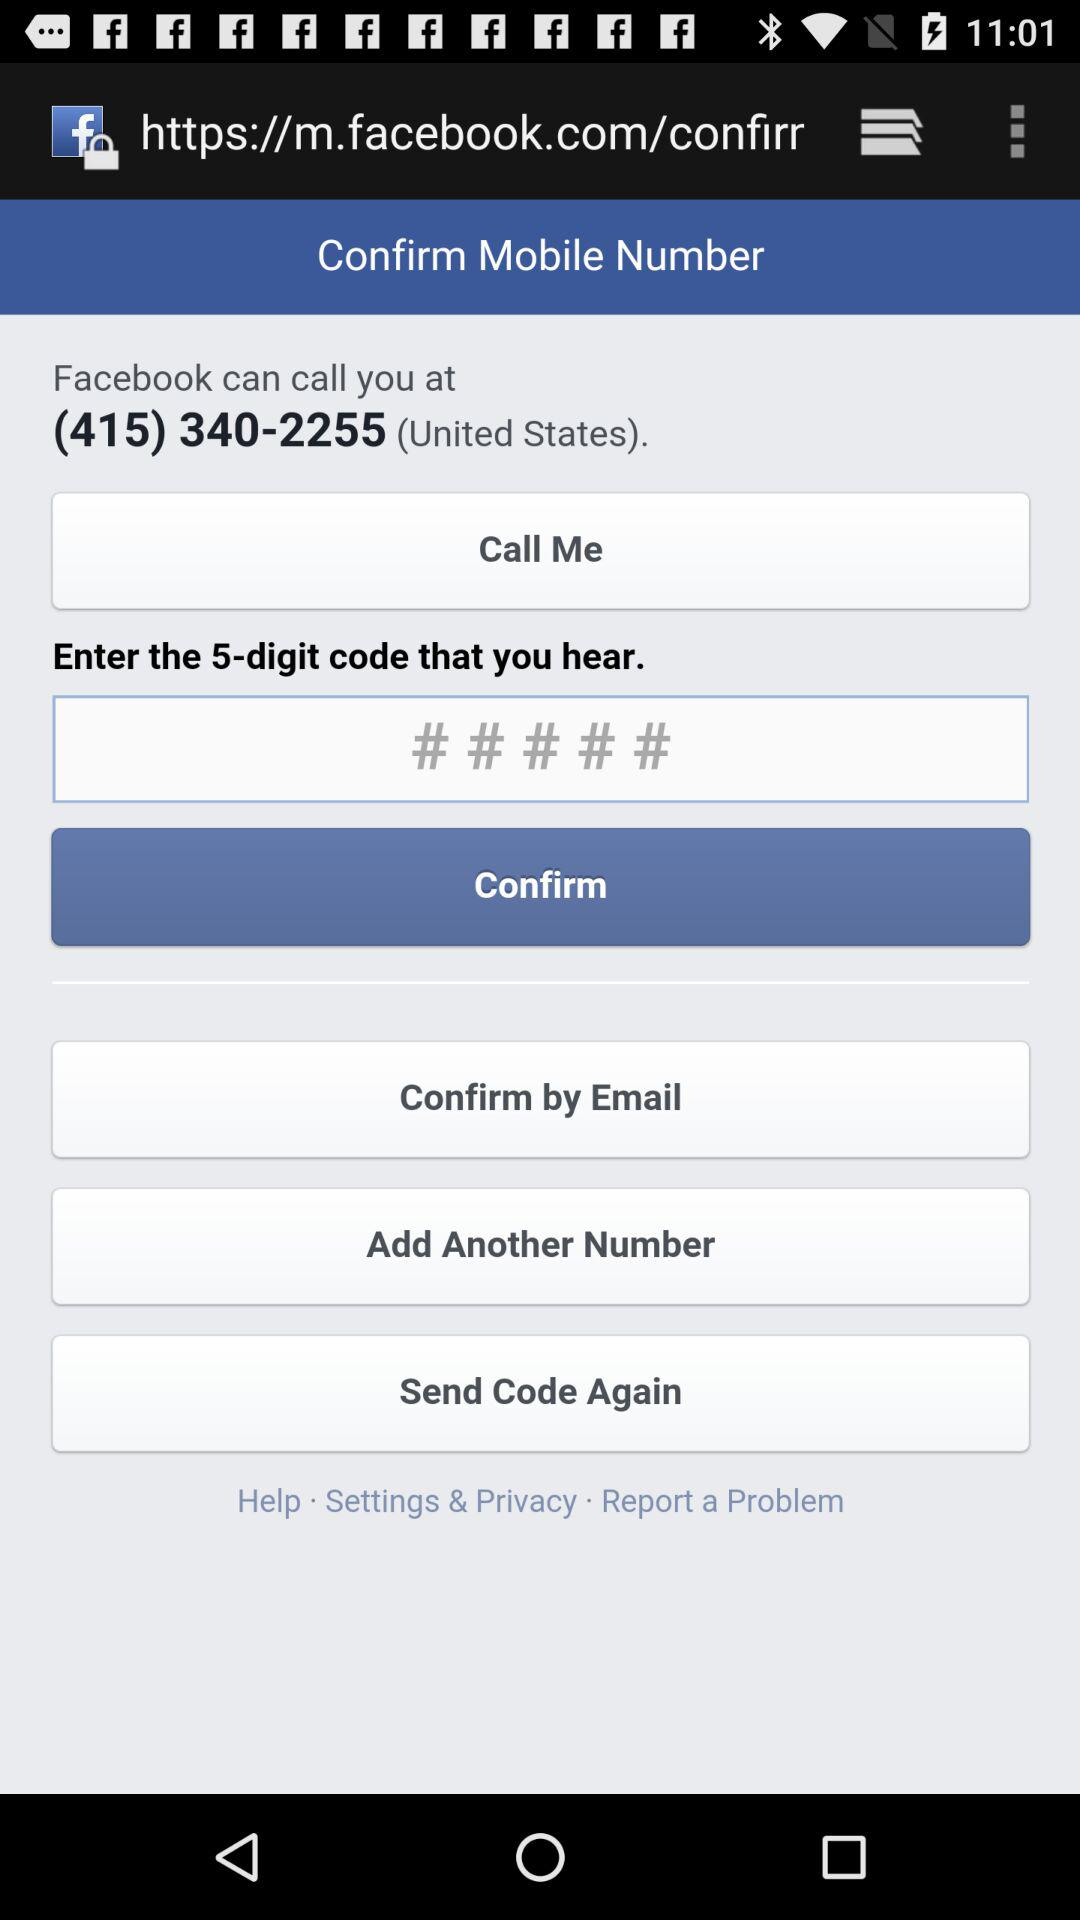What country's phone number is it? It is the phone number of the United States. 